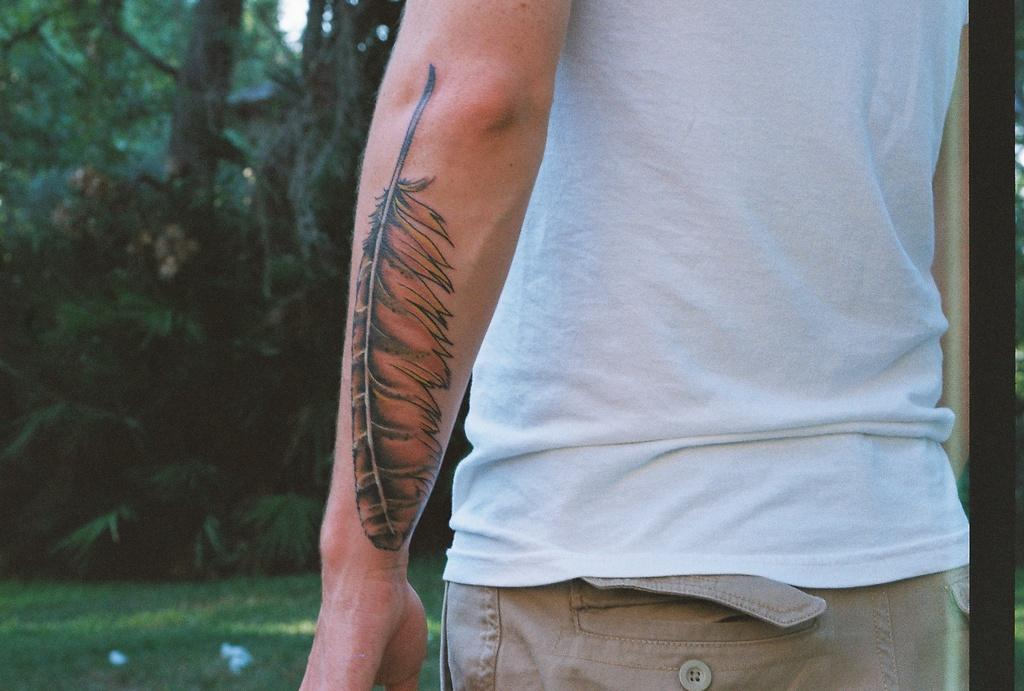What is: What is the main subject of the image? There is a person standing in the image. Can you describe any distinguishing features of the person? The person appears to have a tattoo on their hand. What type of natural environment is visible on the left side of the image? There are trees and grass on the left side of the image. What type of spot can be seen on the person's grandfather in the image? There is no mention of a grandfather or any spots on a person in the image. 